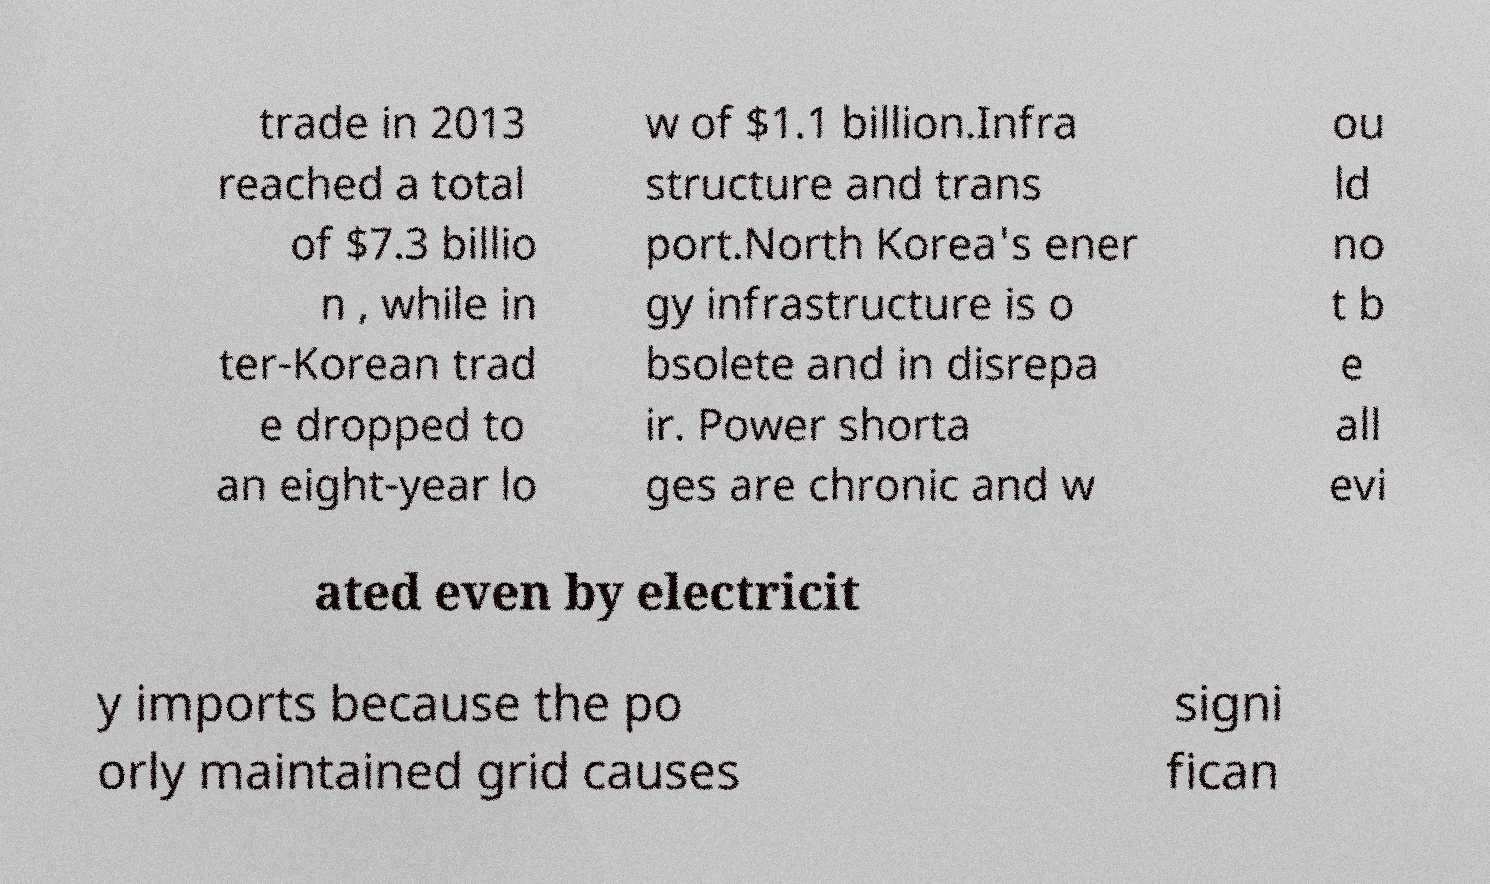Could you extract and type out the text from this image? trade in 2013 reached a total of $7.3 billio n , while in ter-Korean trad e dropped to an eight-year lo w of $1.1 billion.Infra structure and trans port.North Korea's ener gy infrastructure is o bsolete and in disrepa ir. Power shorta ges are chronic and w ou ld no t b e all evi ated even by electricit y imports because the po orly maintained grid causes signi fican 